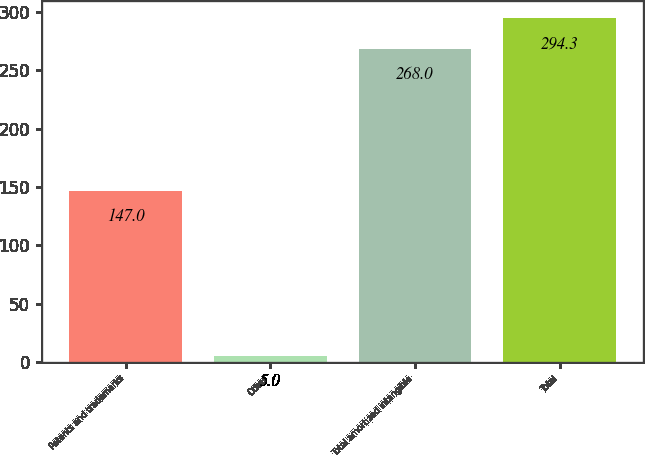Convert chart. <chart><loc_0><loc_0><loc_500><loc_500><bar_chart><fcel>Patents and trademarks<fcel>Other<fcel>Total amortized intangible<fcel>Total<nl><fcel>147<fcel>5<fcel>268<fcel>294.3<nl></chart> 